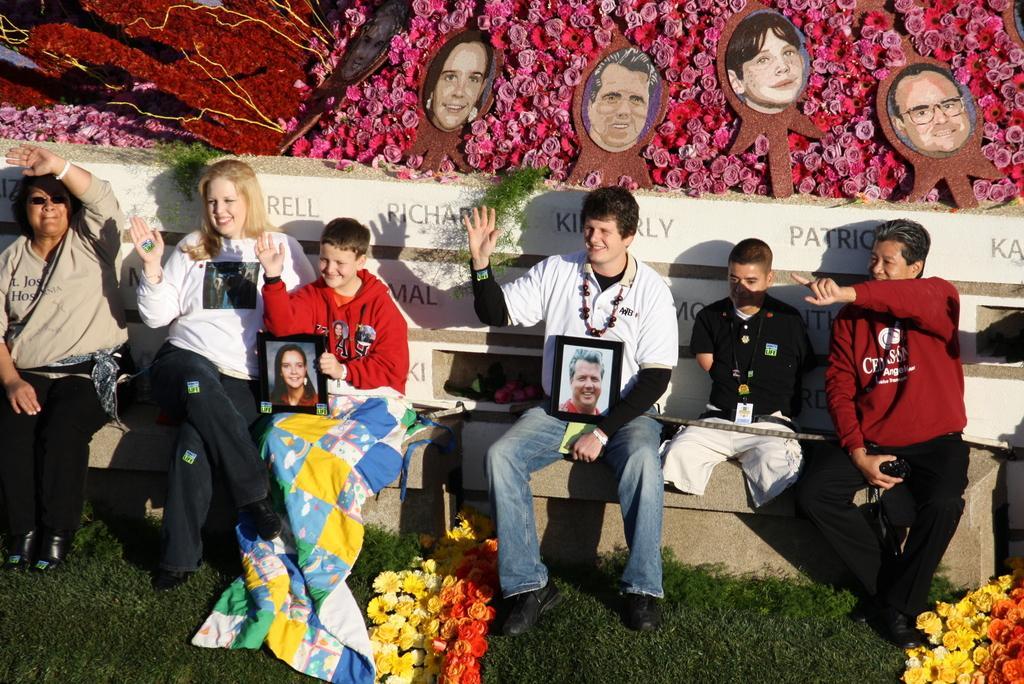In one or two sentences, can you explain what this image depicts? In this picture we can see a group of people sitting on benches and two are holding frames with their hands, flowers, grass and in the background we can see photos. 